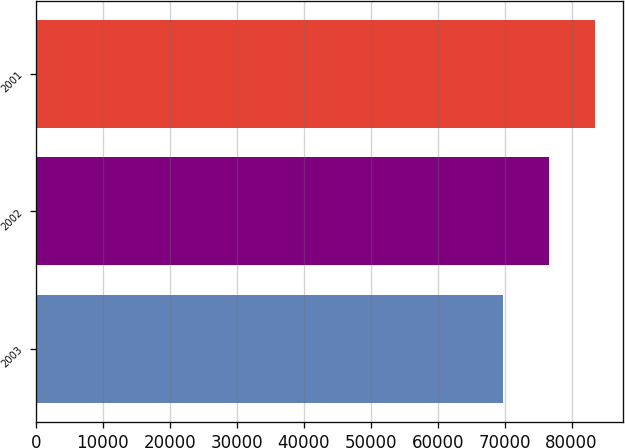<chart> <loc_0><loc_0><loc_500><loc_500><bar_chart><fcel>2003<fcel>2002<fcel>2001<nl><fcel>69744<fcel>76661<fcel>83433<nl></chart> 